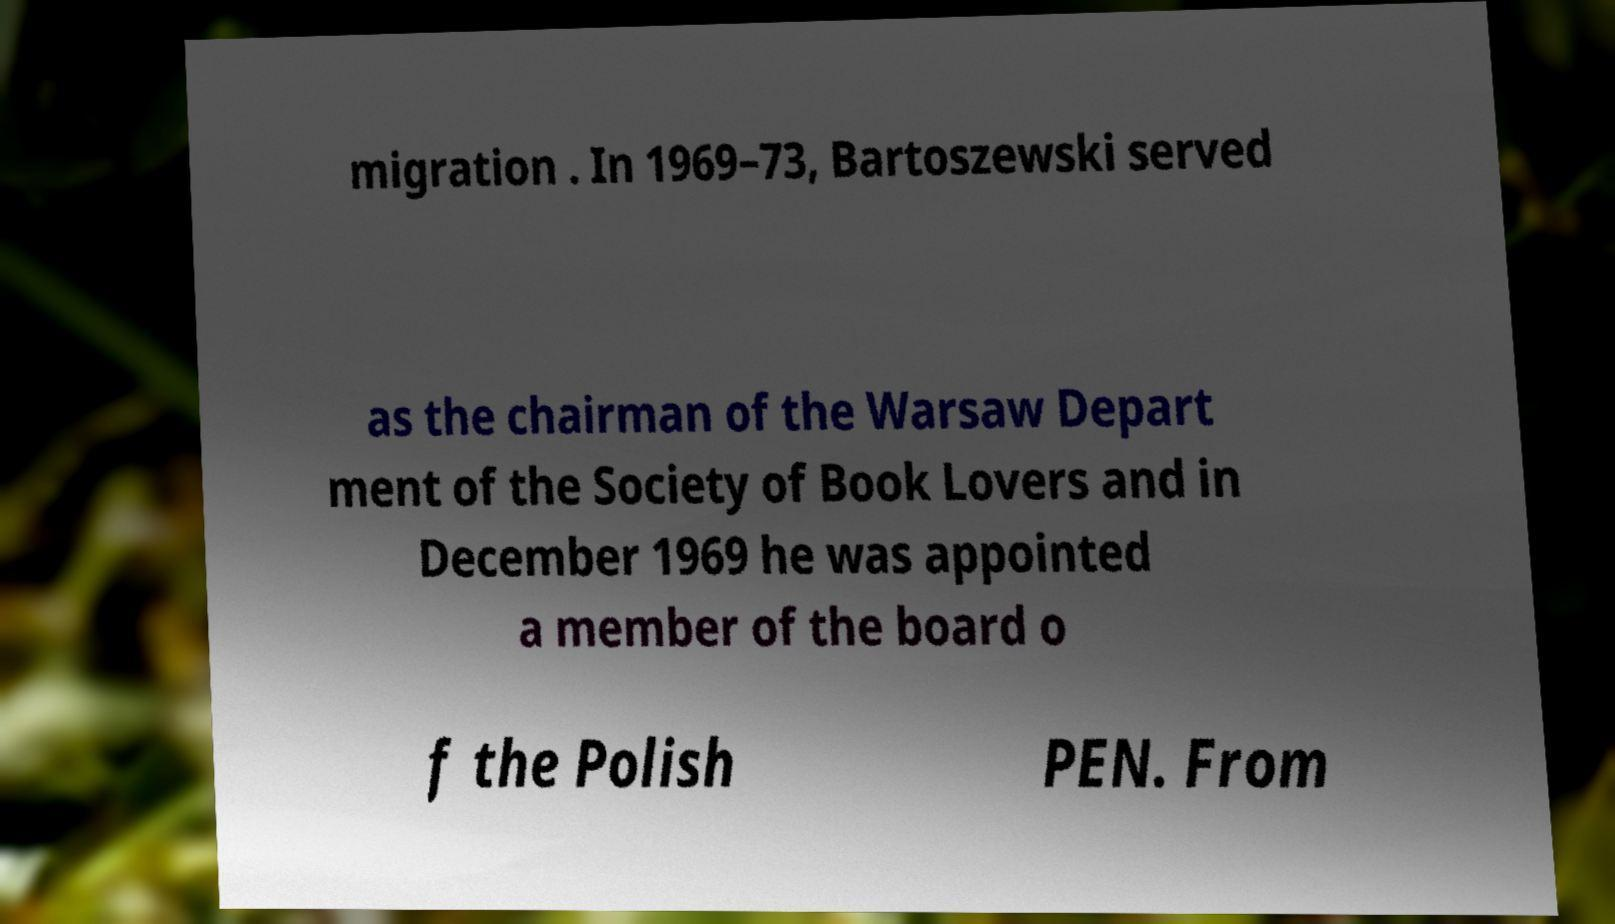Could you extract and type out the text from this image? migration . In 1969–73, Bartoszewski served as the chairman of the Warsaw Depart ment of the Society of Book Lovers and in December 1969 he was appointed a member of the board o f the Polish PEN. From 